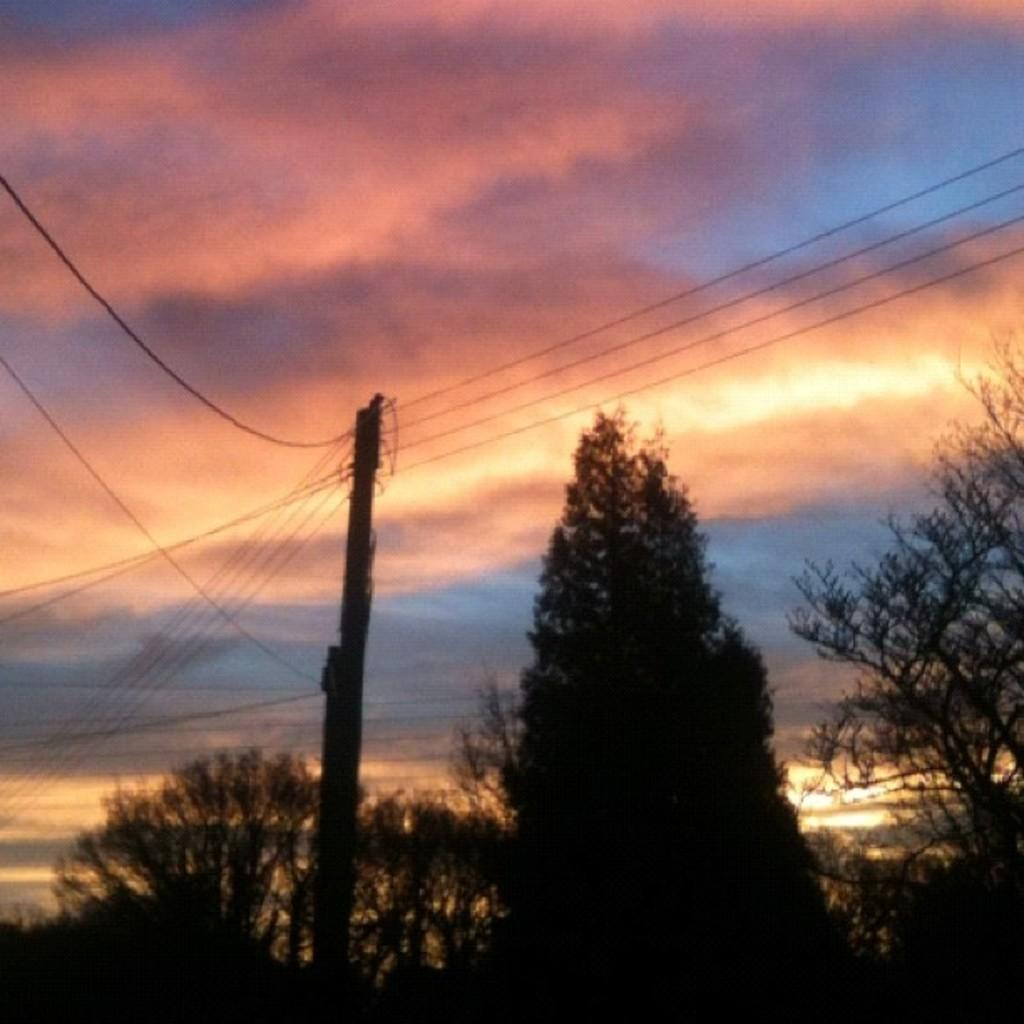What type of vegetation can be seen in the image? There are trees in the image. What is attached to the pole in the image? There are wires on the pole. What is visible at the top of the image? The sky is visible at the top of the image. What can be observed in the sky? There are clouds in the sky, and sunlight is present in the image. How does the sneeze affect the trees in the image? There is no sneeze present in the image, so it cannot affect the trees. What role does the spade play in the image? There is no spade present in the image, so it does not play any role. 